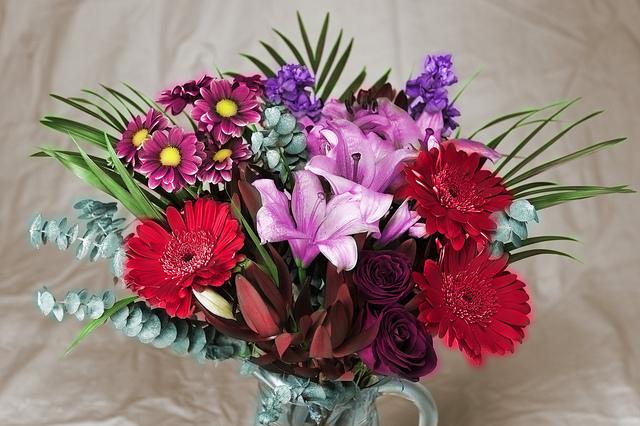Are these flowers artificial?
Give a very brief answer. No. How many different flowers are in the vase?
Give a very brief answer. 5. Does the vase have a handle?
Concise answer only. Yes. 